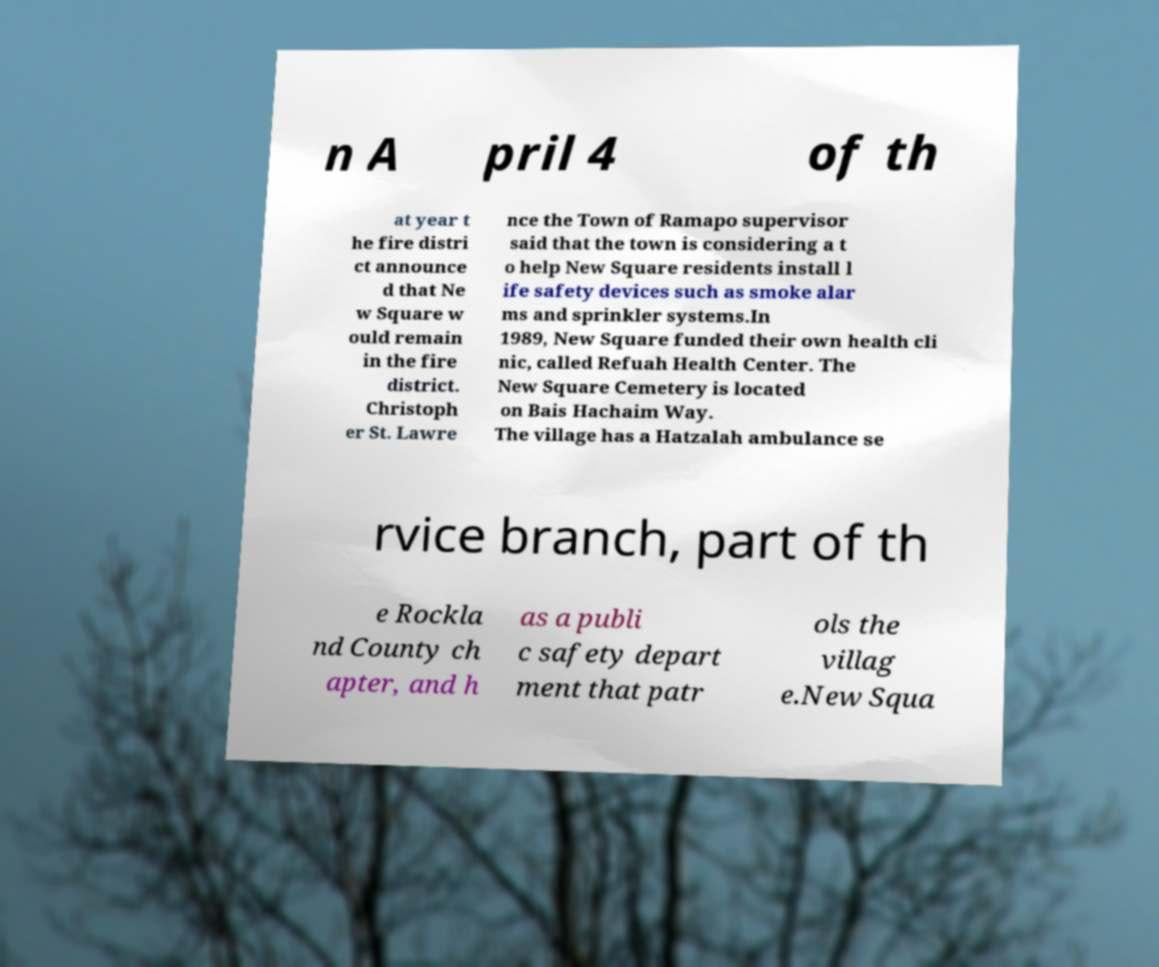What messages or text are displayed in this image? I need them in a readable, typed format. n A pril 4 of th at year t he fire distri ct announce d that Ne w Square w ould remain in the fire district. Christoph er St. Lawre nce the Town of Ramapo supervisor said that the town is considering a t o help New Square residents install l ife safety devices such as smoke alar ms and sprinkler systems.In 1989, New Square funded their own health cli nic, called Refuah Health Center. The New Square Cemetery is located on Bais Hachaim Way. The village has a Hatzalah ambulance se rvice branch, part of th e Rockla nd County ch apter, and h as a publi c safety depart ment that patr ols the villag e.New Squa 